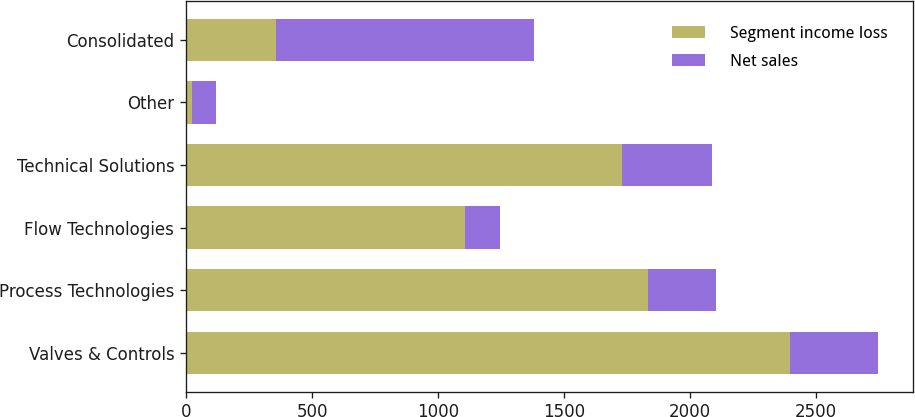Convert chart. <chart><loc_0><loc_0><loc_500><loc_500><stacked_bar_chart><ecel><fcel>Valves & Controls<fcel>Process Technologies<fcel>Flow Technologies<fcel>Technical Solutions<fcel>Other<fcel>Consolidated<nl><fcel>Segment income loss<fcel>2394.8<fcel>1833.2<fcel>1106.6<fcel>1728.1<fcel>23.7<fcel>358.8<nl><fcel>Net sales<fcel>350.8<fcel>267.2<fcel>138.5<fcel>358.8<fcel>93.6<fcel>1021.7<nl></chart> 